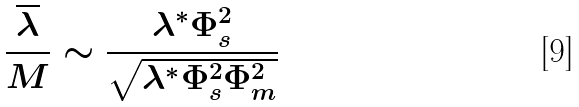Convert formula to latex. <formula><loc_0><loc_0><loc_500><loc_500>\frac { \overline { \lambda } } { M } \sim \frac { \lambda ^ { * } \Phi _ { s } ^ { 2 } } { \sqrt { \lambda ^ { * } \Phi ^ { 2 } _ { s } \Phi _ { m } ^ { 2 } } }</formula> 